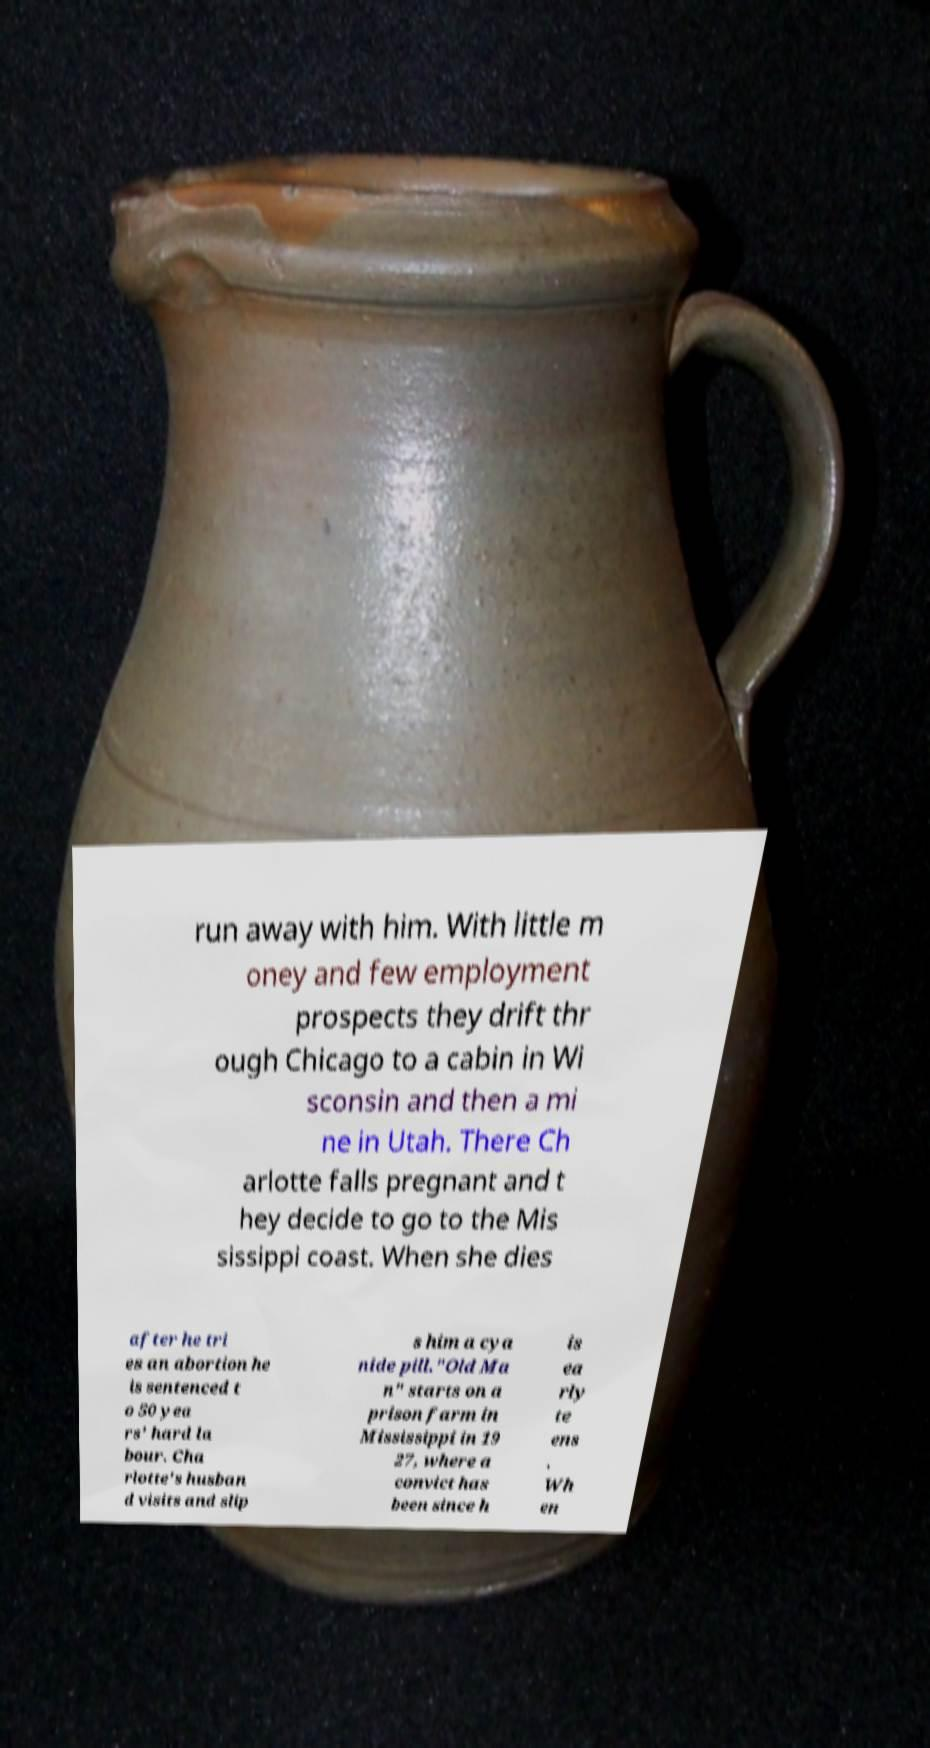I need the written content from this picture converted into text. Can you do that? run away with him. With little m oney and few employment prospects they drift thr ough Chicago to a cabin in Wi sconsin and then a mi ne in Utah. There Ch arlotte falls pregnant and t hey decide to go to the Mis sissippi coast. When she dies after he tri es an abortion he is sentenced t o 50 yea rs' hard la bour. Cha rlotte's husban d visits and slip s him a cya nide pill."Old Ma n" starts on a prison farm in Mississippi in 19 27, where a convict has been since h is ea rly te ens . Wh en 